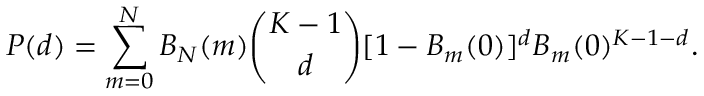Convert formula to latex. <formula><loc_0><loc_0><loc_500><loc_500>P ( d ) = \sum _ { m = 0 } ^ { N } B _ { N } ( m ) \binom { K - 1 } { d } [ 1 - B _ { m } ( 0 ) ] ^ { d } B _ { m } ( 0 ) ^ { K - 1 - d } .</formula> 